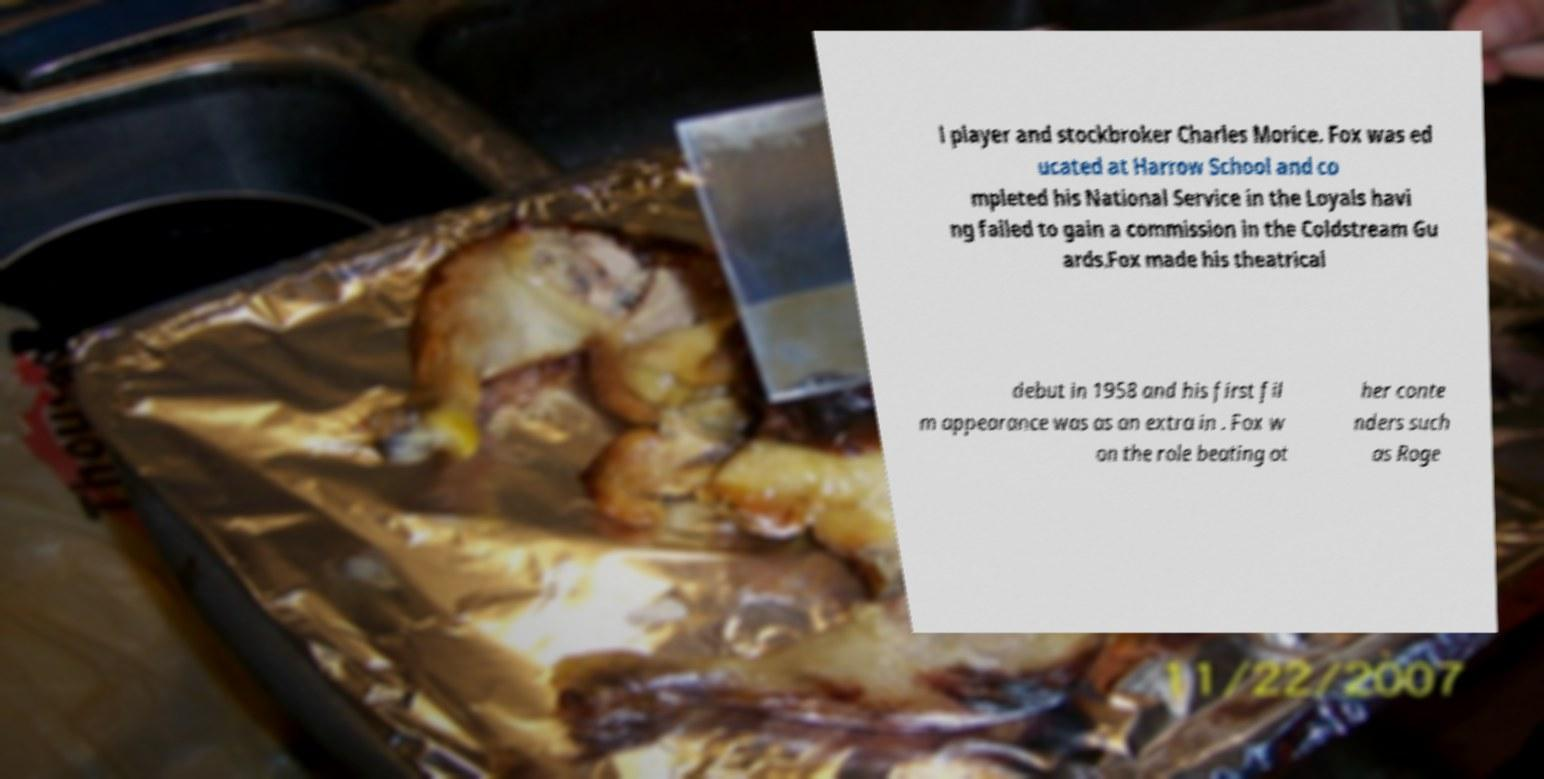I need the written content from this picture converted into text. Can you do that? l player and stockbroker Charles Morice. Fox was ed ucated at Harrow School and co mpleted his National Service in the Loyals havi ng failed to gain a commission in the Coldstream Gu ards.Fox made his theatrical debut in 1958 and his first fil m appearance was as an extra in . Fox w on the role beating ot her conte nders such as Roge 